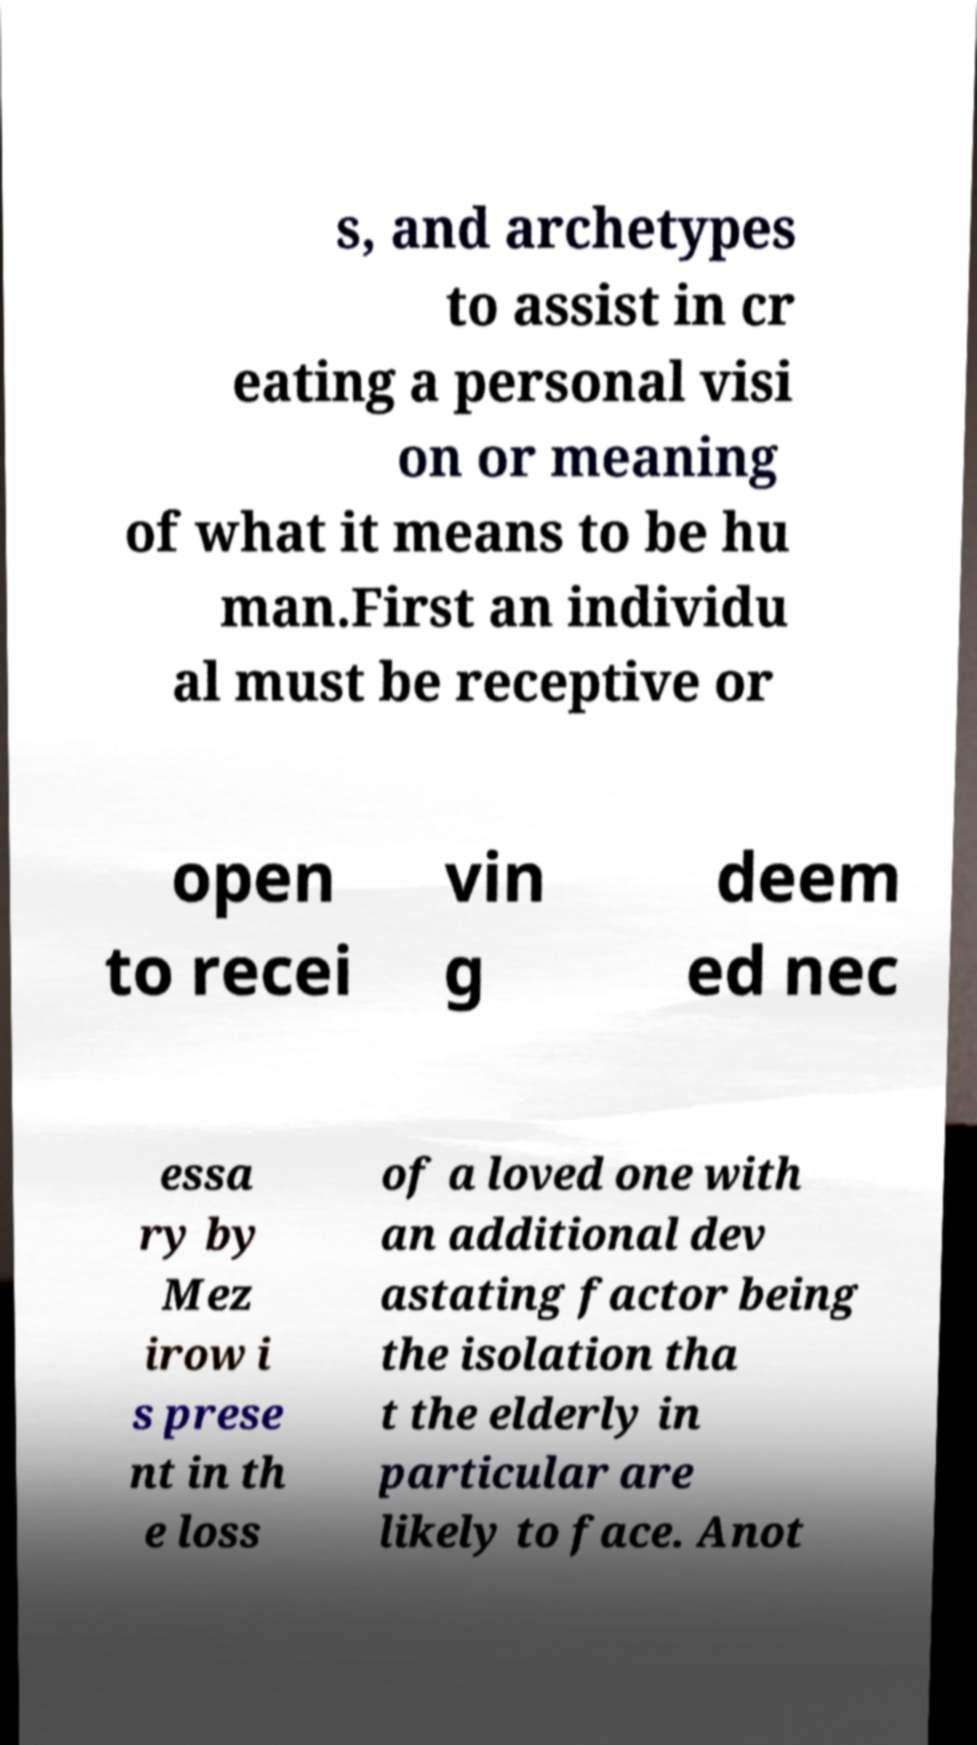For documentation purposes, I need the text within this image transcribed. Could you provide that? s, and archetypes to assist in cr eating a personal visi on or meaning of what it means to be hu man.First an individu al must be receptive or open to recei vin g deem ed nec essa ry by Mez irow i s prese nt in th e loss of a loved one with an additional dev astating factor being the isolation tha t the elderly in particular are likely to face. Anot 